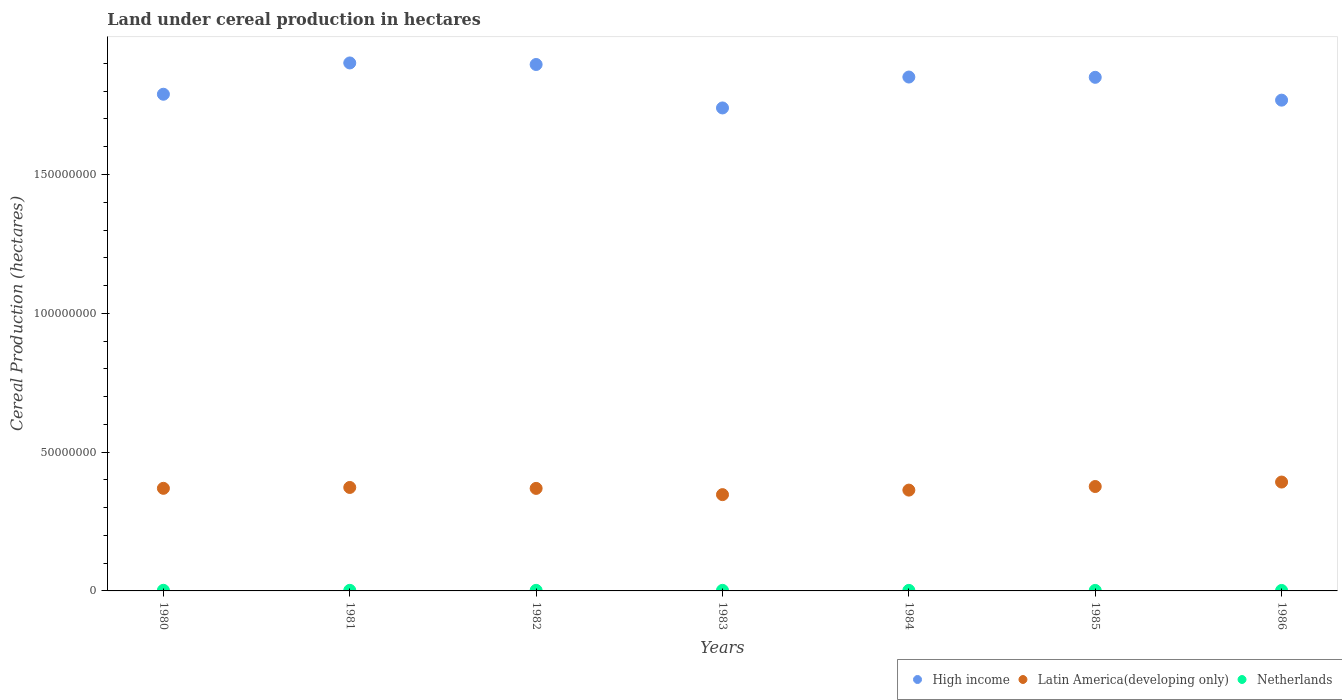What is the land under cereal production in Latin America(developing only) in 1982?
Offer a terse response. 3.69e+07. Across all years, what is the maximum land under cereal production in Latin America(developing only)?
Keep it short and to the point. 3.92e+07. Across all years, what is the minimum land under cereal production in High income?
Offer a very short reply. 1.74e+08. In which year was the land under cereal production in Netherlands minimum?
Ensure brevity in your answer.  1986. What is the total land under cereal production in Netherlands in the graph?
Provide a short and direct response. 1.40e+06. What is the difference between the land under cereal production in Latin America(developing only) in 1983 and that in 1984?
Keep it short and to the point. -1.63e+06. What is the difference between the land under cereal production in Netherlands in 1984 and the land under cereal production in High income in 1982?
Offer a very short reply. -1.89e+08. What is the average land under cereal production in Latin America(developing only) per year?
Offer a very short reply. 3.70e+07. In the year 1983, what is the difference between the land under cereal production in Latin America(developing only) and land under cereal production in High income?
Your answer should be compact. -1.39e+08. What is the ratio of the land under cereal production in Netherlands in 1984 to that in 1985?
Your answer should be compact. 1.07. Is the land under cereal production in Netherlands in 1980 less than that in 1983?
Keep it short and to the point. No. Is the difference between the land under cereal production in Latin America(developing only) in 1984 and 1985 greater than the difference between the land under cereal production in High income in 1984 and 1985?
Make the answer very short. No. What is the difference between the highest and the second highest land under cereal production in Latin America(developing only)?
Ensure brevity in your answer.  1.61e+06. What is the difference between the highest and the lowest land under cereal production in Netherlands?
Offer a terse response. 5.39e+04. Is it the case that in every year, the sum of the land under cereal production in High income and land under cereal production in Latin America(developing only)  is greater than the land under cereal production in Netherlands?
Provide a succinct answer. Yes. Is the land under cereal production in Netherlands strictly less than the land under cereal production in High income over the years?
Keep it short and to the point. Yes. How many dotlines are there?
Give a very brief answer. 3. How many years are there in the graph?
Offer a very short reply. 7. What is the difference between two consecutive major ticks on the Y-axis?
Your answer should be compact. 5.00e+07. Are the values on the major ticks of Y-axis written in scientific E-notation?
Your answer should be very brief. No. How are the legend labels stacked?
Give a very brief answer. Horizontal. What is the title of the graph?
Make the answer very short. Land under cereal production in hectares. Does "Lower middle income" appear as one of the legend labels in the graph?
Your response must be concise. No. What is the label or title of the X-axis?
Your answer should be very brief. Years. What is the label or title of the Y-axis?
Provide a succinct answer. Cereal Production (hectares). What is the Cereal Production (hectares) of High income in 1980?
Offer a terse response. 1.79e+08. What is the Cereal Production (hectares) in Latin America(developing only) in 1980?
Your answer should be very brief. 3.70e+07. What is the Cereal Production (hectares) of Netherlands in 1980?
Give a very brief answer. 2.24e+05. What is the Cereal Production (hectares) of High income in 1981?
Give a very brief answer. 1.90e+08. What is the Cereal Production (hectares) in Latin America(developing only) in 1981?
Your response must be concise. 3.73e+07. What is the Cereal Production (hectares) of Netherlands in 1981?
Offer a very short reply. 2.13e+05. What is the Cereal Production (hectares) of High income in 1982?
Ensure brevity in your answer.  1.90e+08. What is the Cereal Production (hectares) of Latin America(developing only) in 1982?
Make the answer very short. 3.69e+07. What is the Cereal Production (hectares) in Netherlands in 1982?
Provide a succinct answer. 2.05e+05. What is the Cereal Production (hectares) in High income in 1983?
Ensure brevity in your answer.  1.74e+08. What is the Cereal Production (hectares) in Latin America(developing only) in 1983?
Make the answer very short. 3.47e+07. What is the Cereal Production (hectares) of Netherlands in 1983?
Provide a short and direct response. 2.06e+05. What is the Cereal Production (hectares) of High income in 1984?
Give a very brief answer. 1.85e+08. What is the Cereal Production (hectares) of Latin America(developing only) in 1984?
Make the answer very short. 3.63e+07. What is the Cereal Production (hectares) in Netherlands in 1984?
Your answer should be compact. 1.96e+05. What is the Cereal Production (hectares) of High income in 1985?
Your response must be concise. 1.85e+08. What is the Cereal Production (hectares) in Latin America(developing only) in 1985?
Make the answer very short. 3.76e+07. What is the Cereal Production (hectares) of Netherlands in 1985?
Your response must be concise. 1.83e+05. What is the Cereal Production (hectares) in High income in 1986?
Your response must be concise. 1.77e+08. What is the Cereal Production (hectares) of Latin America(developing only) in 1986?
Your response must be concise. 3.92e+07. What is the Cereal Production (hectares) in Netherlands in 1986?
Offer a very short reply. 1.70e+05. Across all years, what is the maximum Cereal Production (hectares) of High income?
Provide a short and direct response. 1.90e+08. Across all years, what is the maximum Cereal Production (hectares) of Latin America(developing only)?
Your response must be concise. 3.92e+07. Across all years, what is the maximum Cereal Production (hectares) in Netherlands?
Keep it short and to the point. 2.24e+05. Across all years, what is the minimum Cereal Production (hectares) of High income?
Your response must be concise. 1.74e+08. Across all years, what is the minimum Cereal Production (hectares) in Latin America(developing only)?
Your answer should be very brief. 3.47e+07. Across all years, what is the minimum Cereal Production (hectares) of Netherlands?
Give a very brief answer. 1.70e+05. What is the total Cereal Production (hectares) in High income in the graph?
Give a very brief answer. 1.28e+09. What is the total Cereal Production (hectares) of Latin America(developing only) in the graph?
Your answer should be compact. 2.59e+08. What is the total Cereal Production (hectares) in Netherlands in the graph?
Ensure brevity in your answer.  1.40e+06. What is the difference between the Cereal Production (hectares) of High income in 1980 and that in 1981?
Provide a succinct answer. -1.13e+07. What is the difference between the Cereal Production (hectares) in Latin America(developing only) in 1980 and that in 1981?
Offer a terse response. -3.14e+05. What is the difference between the Cereal Production (hectares) of Netherlands in 1980 and that in 1981?
Ensure brevity in your answer.  1.08e+04. What is the difference between the Cereal Production (hectares) of High income in 1980 and that in 1982?
Ensure brevity in your answer.  -1.07e+07. What is the difference between the Cereal Production (hectares) in Latin America(developing only) in 1980 and that in 1982?
Offer a very short reply. 2.49e+04. What is the difference between the Cereal Production (hectares) of Netherlands in 1980 and that in 1982?
Your answer should be compact. 1.95e+04. What is the difference between the Cereal Production (hectares) of High income in 1980 and that in 1983?
Offer a terse response. 4.94e+06. What is the difference between the Cereal Production (hectares) in Latin America(developing only) in 1980 and that in 1983?
Provide a succinct answer. 2.27e+06. What is the difference between the Cereal Production (hectares) of Netherlands in 1980 and that in 1983?
Your answer should be very brief. 1.80e+04. What is the difference between the Cereal Production (hectares) of High income in 1980 and that in 1984?
Ensure brevity in your answer.  -6.20e+06. What is the difference between the Cereal Production (hectares) of Latin America(developing only) in 1980 and that in 1984?
Give a very brief answer. 6.42e+05. What is the difference between the Cereal Production (hectares) of Netherlands in 1980 and that in 1984?
Provide a short and direct response. 2.84e+04. What is the difference between the Cereal Production (hectares) of High income in 1980 and that in 1985?
Your answer should be compact. -6.10e+06. What is the difference between the Cereal Production (hectares) of Latin America(developing only) in 1980 and that in 1985?
Your response must be concise. -6.54e+05. What is the difference between the Cereal Production (hectares) in Netherlands in 1980 and that in 1985?
Give a very brief answer. 4.07e+04. What is the difference between the Cereal Production (hectares) in High income in 1980 and that in 1986?
Provide a short and direct response. 2.13e+06. What is the difference between the Cereal Production (hectares) of Latin America(developing only) in 1980 and that in 1986?
Give a very brief answer. -2.26e+06. What is the difference between the Cereal Production (hectares) of Netherlands in 1980 and that in 1986?
Your response must be concise. 5.39e+04. What is the difference between the Cereal Production (hectares) of High income in 1981 and that in 1982?
Give a very brief answer. 5.56e+05. What is the difference between the Cereal Production (hectares) of Latin America(developing only) in 1981 and that in 1982?
Provide a short and direct response. 3.39e+05. What is the difference between the Cereal Production (hectares) in Netherlands in 1981 and that in 1982?
Ensure brevity in your answer.  8707. What is the difference between the Cereal Production (hectares) in High income in 1981 and that in 1983?
Ensure brevity in your answer.  1.62e+07. What is the difference between the Cereal Production (hectares) of Latin America(developing only) in 1981 and that in 1983?
Ensure brevity in your answer.  2.59e+06. What is the difference between the Cereal Production (hectares) of Netherlands in 1981 and that in 1983?
Keep it short and to the point. 7226. What is the difference between the Cereal Production (hectares) of High income in 1981 and that in 1984?
Provide a short and direct response. 5.07e+06. What is the difference between the Cereal Production (hectares) in Latin America(developing only) in 1981 and that in 1984?
Your answer should be compact. 9.56e+05. What is the difference between the Cereal Production (hectares) in Netherlands in 1981 and that in 1984?
Your answer should be very brief. 1.76e+04. What is the difference between the Cereal Production (hectares) of High income in 1981 and that in 1985?
Give a very brief answer. 5.18e+06. What is the difference between the Cereal Production (hectares) in Latin America(developing only) in 1981 and that in 1985?
Give a very brief answer. -3.40e+05. What is the difference between the Cereal Production (hectares) of Netherlands in 1981 and that in 1985?
Give a very brief answer. 2.99e+04. What is the difference between the Cereal Production (hectares) in High income in 1981 and that in 1986?
Make the answer very short. 1.34e+07. What is the difference between the Cereal Production (hectares) of Latin America(developing only) in 1981 and that in 1986?
Your answer should be very brief. -1.95e+06. What is the difference between the Cereal Production (hectares) in Netherlands in 1981 and that in 1986?
Your response must be concise. 4.31e+04. What is the difference between the Cereal Production (hectares) of High income in 1982 and that in 1983?
Make the answer very short. 1.57e+07. What is the difference between the Cereal Production (hectares) of Latin America(developing only) in 1982 and that in 1983?
Provide a short and direct response. 2.25e+06. What is the difference between the Cereal Production (hectares) of Netherlands in 1982 and that in 1983?
Your response must be concise. -1481. What is the difference between the Cereal Production (hectares) in High income in 1982 and that in 1984?
Provide a succinct answer. 4.52e+06. What is the difference between the Cereal Production (hectares) in Latin America(developing only) in 1982 and that in 1984?
Your answer should be very brief. 6.17e+05. What is the difference between the Cereal Production (hectares) in Netherlands in 1982 and that in 1984?
Ensure brevity in your answer.  8897. What is the difference between the Cereal Production (hectares) in High income in 1982 and that in 1985?
Ensure brevity in your answer.  4.62e+06. What is the difference between the Cereal Production (hectares) in Latin America(developing only) in 1982 and that in 1985?
Keep it short and to the point. -6.79e+05. What is the difference between the Cereal Production (hectares) of Netherlands in 1982 and that in 1985?
Offer a terse response. 2.12e+04. What is the difference between the Cereal Production (hectares) of High income in 1982 and that in 1986?
Provide a short and direct response. 1.28e+07. What is the difference between the Cereal Production (hectares) of Latin America(developing only) in 1982 and that in 1986?
Give a very brief answer. -2.28e+06. What is the difference between the Cereal Production (hectares) of Netherlands in 1982 and that in 1986?
Your answer should be compact. 3.43e+04. What is the difference between the Cereal Production (hectares) in High income in 1983 and that in 1984?
Ensure brevity in your answer.  -1.11e+07. What is the difference between the Cereal Production (hectares) of Latin America(developing only) in 1983 and that in 1984?
Make the answer very short. -1.63e+06. What is the difference between the Cereal Production (hectares) in Netherlands in 1983 and that in 1984?
Offer a terse response. 1.04e+04. What is the difference between the Cereal Production (hectares) of High income in 1983 and that in 1985?
Keep it short and to the point. -1.10e+07. What is the difference between the Cereal Production (hectares) in Latin America(developing only) in 1983 and that in 1985?
Provide a short and direct response. -2.93e+06. What is the difference between the Cereal Production (hectares) in Netherlands in 1983 and that in 1985?
Offer a very short reply. 2.27e+04. What is the difference between the Cereal Production (hectares) of High income in 1983 and that in 1986?
Ensure brevity in your answer.  -2.81e+06. What is the difference between the Cereal Production (hectares) in Latin America(developing only) in 1983 and that in 1986?
Give a very brief answer. -4.53e+06. What is the difference between the Cereal Production (hectares) in Netherlands in 1983 and that in 1986?
Offer a very short reply. 3.58e+04. What is the difference between the Cereal Production (hectares) in High income in 1984 and that in 1985?
Provide a short and direct response. 1.01e+05. What is the difference between the Cereal Production (hectares) of Latin America(developing only) in 1984 and that in 1985?
Offer a terse response. -1.30e+06. What is the difference between the Cereal Production (hectares) of Netherlands in 1984 and that in 1985?
Give a very brief answer. 1.23e+04. What is the difference between the Cereal Production (hectares) of High income in 1984 and that in 1986?
Make the answer very short. 8.32e+06. What is the difference between the Cereal Production (hectares) in Latin America(developing only) in 1984 and that in 1986?
Offer a very short reply. -2.90e+06. What is the difference between the Cereal Production (hectares) in Netherlands in 1984 and that in 1986?
Your answer should be very brief. 2.54e+04. What is the difference between the Cereal Production (hectares) in High income in 1985 and that in 1986?
Provide a short and direct response. 8.22e+06. What is the difference between the Cereal Production (hectares) in Latin America(developing only) in 1985 and that in 1986?
Make the answer very short. -1.61e+06. What is the difference between the Cereal Production (hectares) in Netherlands in 1985 and that in 1986?
Your answer should be very brief. 1.31e+04. What is the difference between the Cereal Production (hectares) in High income in 1980 and the Cereal Production (hectares) in Latin America(developing only) in 1981?
Your answer should be compact. 1.42e+08. What is the difference between the Cereal Production (hectares) in High income in 1980 and the Cereal Production (hectares) in Netherlands in 1981?
Give a very brief answer. 1.79e+08. What is the difference between the Cereal Production (hectares) of Latin America(developing only) in 1980 and the Cereal Production (hectares) of Netherlands in 1981?
Give a very brief answer. 3.67e+07. What is the difference between the Cereal Production (hectares) in High income in 1980 and the Cereal Production (hectares) in Latin America(developing only) in 1982?
Your response must be concise. 1.42e+08. What is the difference between the Cereal Production (hectares) of High income in 1980 and the Cereal Production (hectares) of Netherlands in 1982?
Provide a short and direct response. 1.79e+08. What is the difference between the Cereal Production (hectares) of Latin America(developing only) in 1980 and the Cereal Production (hectares) of Netherlands in 1982?
Give a very brief answer. 3.68e+07. What is the difference between the Cereal Production (hectares) in High income in 1980 and the Cereal Production (hectares) in Latin America(developing only) in 1983?
Give a very brief answer. 1.44e+08. What is the difference between the Cereal Production (hectares) in High income in 1980 and the Cereal Production (hectares) in Netherlands in 1983?
Ensure brevity in your answer.  1.79e+08. What is the difference between the Cereal Production (hectares) in Latin America(developing only) in 1980 and the Cereal Production (hectares) in Netherlands in 1983?
Provide a succinct answer. 3.68e+07. What is the difference between the Cereal Production (hectares) of High income in 1980 and the Cereal Production (hectares) of Latin America(developing only) in 1984?
Make the answer very short. 1.43e+08. What is the difference between the Cereal Production (hectares) of High income in 1980 and the Cereal Production (hectares) of Netherlands in 1984?
Your response must be concise. 1.79e+08. What is the difference between the Cereal Production (hectares) of Latin America(developing only) in 1980 and the Cereal Production (hectares) of Netherlands in 1984?
Provide a short and direct response. 3.68e+07. What is the difference between the Cereal Production (hectares) in High income in 1980 and the Cereal Production (hectares) in Latin America(developing only) in 1985?
Offer a very short reply. 1.41e+08. What is the difference between the Cereal Production (hectares) of High income in 1980 and the Cereal Production (hectares) of Netherlands in 1985?
Your answer should be compact. 1.79e+08. What is the difference between the Cereal Production (hectares) in Latin America(developing only) in 1980 and the Cereal Production (hectares) in Netherlands in 1985?
Your response must be concise. 3.68e+07. What is the difference between the Cereal Production (hectares) in High income in 1980 and the Cereal Production (hectares) in Latin America(developing only) in 1986?
Provide a short and direct response. 1.40e+08. What is the difference between the Cereal Production (hectares) of High income in 1980 and the Cereal Production (hectares) of Netherlands in 1986?
Offer a very short reply. 1.79e+08. What is the difference between the Cereal Production (hectares) in Latin America(developing only) in 1980 and the Cereal Production (hectares) in Netherlands in 1986?
Your response must be concise. 3.68e+07. What is the difference between the Cereal Production (hectares) in High income in 1981 and the Cereal Production (hectares) in Latin America(developing only) in 1982?
Provide a short and direct response. 1.53e+08. What is the difference between the Cereal Production (hectares) in High income in 1981 and the Cereal Production (hectares) in Netherlands in 1982?
Keep it short and to the point. 1.90e+08. What is the difference between the Cereal Production (hectares) of Latin America(developing only) in 1981 and the Cereal Production (hectares) of Netherlands in 1982?
Offer a terse response. 3.71e+07. What is the difference between the Cereal Production (hectares) of High income in 1981 and the Cereal Production (hectares) of Latin America(developing only) in 1983?
Make the answer very short. 1.56e+08. What is the difference between the Cereal Production (hectares) of High income in 1981 and the Cereal Production (hectares) of Netherlands in 1983?
Offer a terse response. 1.90e+08. What is the difference between the Cereal Production (hectares) of Latin America(developing only) in 1981 and the Cereal Production (hectares) of Netherlands in 1983?
Offer a terse response. 3.71e+07. What is the difference between the Cereal Production (hectares) in High income in 1981 and the Cereal Production (hectares) in Latin America(developing only) in 1984?
Your answer should be very brief. 1.54e+08. What is the difference between the Cereal Production (hectares) of High income in 1981 and the Cereal Production (hectares) of Netherlands in 1984?
Make the answer very short. 1.90e+08. What is the difference between the Cereal Production (hectares) in Latin America(developing only) in 1981 and the Cereal Production (hectares) in Netherlands in 1984?
Make the answer very short. 3.71e+07. What is the difference between the Cereal Production (hectares) in High income in 1981 and the Cereal Production (hectares) in Latin America(developing only) in 1985?
Your answer should be very brief. 1.53e+08. What is the difference between the Cereal Production (hectares) in High income in 1981 and the Cereal Production (hectares) in Netherlands in 1985?
Your answer should be compact. 1.90e+08. What is the difference between the Cereal Production (hectares) of Latin America(developing only) in 1981 and the Cereal Production (hectares) of Netherlands in 1985?
Provide a succinct answer. 3.71e+07. What is the difference between the Cereal Production (hectares) of High income in 1981 and the Cereal Production (hectares) of Latin America(developing only) in 1986?
Offer a terse response. 1.51e+08. What is the difference between the Cereal Production (hectares) of High income in 1981 and the Cereal Production (hectares) of Netherlands in 1986?
Your answer should be compact. 1.90e+08. What is the difference between the Cereal Production (hectares) of Latin America(developing only) in 1981 and the Cereal Production (hectares) of Netherlands in 1986?
Give a very brief answer. 3.71e+07. What is the difference between the Cereal Production (hectares) in High income in 1982 and the Cereal Production (hectares) in Latin America(developing only) in 1983?
Ensure brevity in your answer.  1.55e+08. What is the difference between the Cereal Production (hectares) in High income in 1982 and the Cereal Production (hectares) in Netherlands in 1983?
Provide a short and direct response. 1.89e+08. What is the difference between the Cereal Production (hectares) of Latin America(developing only) in 1982 and the Cereal Production (hectares) of Netherlands in 1983?
Provide a short and direct response. 3.67e+07. What is the difference between the Cereal Production (hectares) of High income in 1982 and the Cereal Production (hectares) of Latin America(developing only) in 1984?
Your answer should be very brief. 1.53e+08. What is the difference between the Cereal Production (hectares) of High income in 1982 and the Cereal Production (hectares) of Netherlands in 1984?
Keep it short and to the point. 1.89e+08. What is the difference between the Cereal Production (hectares) in Latin America(developing only) in 1982 and the Cereal Production (hectares) in Netherlands in 1984?
Offer a very short reply. 3.67e+07. What is the difference between the Cereal Production (hectares) in High income in 1982 and the Cereal Production (hectares) in Latin America(developing only) in 1985?
Give a very brief answer. 1.52e+08. What is the difference between the Cereal Production (hectares) of High income in 1982 and the Cereal Production (hectares) of Netherlands in 1985?
Make the answer very short. 1.89e+08. What is the difference between the Cereal Production (hectares) in Latin America(developing only) in 1982 and the Cereal Production (hectares) in Netherlands in 1985?
Ensure brevity in your answer.  3.67e+07. What is the difference between the Cereal Production (hectares) in High income in 1982 and the Cereal Production (hectares) in Latin America(developing only) in 1986?
Your answer should be very brief. 1.50e+08. What is the difference between the Cereal Production (hectares) in High income in 1982 and the Cereal Production (hectares) in Netherlands in 1986?
Your answer should be compact. 1.89e+08. What is the difference between the Cereal Production (hectares) in Latin America(developing only) in 1982 and the Cereal Production (hectares) in Netherlands in 1986?
Your answer should be very brief. 3.68e+07. What is the difference between the Cereal Production (hectares) in High income in 1983 and the Cereal Production (hectares) in Latin America(developing only) in 1984?
Offer a very short reply. 1.38e+08. What is the difference between the Cereal Production (hectares) in High income in 1983 and the Cereal Production (hectares) in Netherlands in 1984?
Offer a very short reply. 1.74e+08. What is the difference between the Cereal Production (hectares) in Latin America(developing only) in 1983 and the Cereal Production (hectares) in Netherlands in 1984?
Provide a short and direct response. 3.45e+07. What is the difference between the Cereal Production (hectares) of High income in 1983 and the Cereal Production (hectares) of Latin America(developing only) in 1985?
Make the answer very short. 1.36e+08. What is the difference between the Cereal Production (hectares) of High income in 1983 and the Cereal Production (hectares) of Netherlands in 1985?
Your answer should be compact. 1.74e+08. What is the difference between the Cereal Production (hectares) in Latin America(developing only) in 1983 and the Cereal Production (hectares) in Netherlands in 1985?
Make the answer very short. 3.45e+07. What is the difference between the Cereal Production (hectares) in High income in 1983 and the Cereal Production (hectares) in Latin America(developing only) in 1986?
Give a very brief answer. 1.35e+08. What is the difference between the Cereal Production (hectares) of High income in 1983 and the Cereal Production (hectares) of Netherlands in 1986?
Your answer should be very brief. 1.74e+08. What is the difference between the Cereal Production (hectares) in Latin America(developing only) in 1983 and the Cereal Production (hectares) in Netherlands in 1986?
Give a very brief answer. 3.45e+07. What is the difference between the Cereal Production (hectares) in High income in 1984 and the Cereal Production (hectares) in Latin America(developing only) in 1985?
Your answer should be very brief. 1.48e+08. What is the difference between the Cereal Production (hectares) in High income in 1984 and the Cereal Production (hectares) in Netherlands in 1985?
Make the answer very short. 1.85e+08. What is the difference between the Cereal Production (hectares) in Latin America(developing only) in 1984 and the Cereal Production (hectares) in Netherlands in 1985?
Give a very brief answer. 3.61e+07. What is the difference between the Cereal Production (hectares) in High income in 1984 and the Cereal Production (hectares) in Latin America(developing only) in 1986?
Offer a terse response. 1.46e+08. What is the difference between the Cereal Production (hectares) of High income in 1984 and the Cereal Production (hectares) of Netherlands in 1986?
Ensure brevity in your answer.  1.85e+08. What is the difference between the Cereal Production (hectares) of Latin America(developing only) in 1984 and the Cereal Production (hectares) of Netherlands in 1986?
Keep it short and to the point. 3.61e+07. What is the difference between the Cereal Production (hectares) in High income in 1985 and the Cereal Production (hectares) in Latin America(developing only) in 1986?
Offer a very short reply. 1.46e+08. What is the difference between the Cereal Production (hectares) in High income in 1985 and the Cereal Production (hectares) in Netherlands in 1986?
Give a very brief answer. 1.85e+08. What is the difference between the Cereal Production (hectares) of Latin America(developing only) in 1985 and the Cereal Production (hectares) of Netherlands in 1986?
Provide a succinct answer. 3.74e+07. What is the average Cereal Production (hectares) in High income per year?
Provide a short and direct response. 1.83e+08. What is the average Cereal Production (hectares) of Latin America(developing only) per year?
Offer a terse response. 3.70e+07. What is the average Cereal Production (hectares) of Netherlands per year?
Your answer should be compact. 2.00e+05. In the year 1980, what is the difference between the Cereal Production (hectares) of High income and Cereal Production (hectares) of Latin America(developing only)?
Make the answer very short. 1.42e+08. In the year 1980, what is the difference between the Cereal Production (hectares) of High income and Cereal Production (hectares) of Netherlands?
Provide a succinct answer. 1.79e+08. In the year 1980, what is the difference between the Cereal Production (hectares) of Latin America(developing only) and Cereal Production (hectares) of Netherlands?
Offer a very short reply. 3.67e+07. In the year 1981, what is the difference between the Cereal Production (hectares) of High income and Cereal Production (hectares) of Latin America(developing only)?
Offer a terse response. 1.53e+08. In the year 1981, what is the difference between the Cereal Production (hectares) of High income and Cereal Production (hectares) of Netherlands?
Provide a short and direct response. 1.90e+08. In the year 1981, what is the difference between the Cereal Production (hectares) of Latin America(developing only) and Cereal Production (hectares) of Netherlands?
Give a very brief answer. 3.71e+07. In the year 1982, what is the difference between the Cereal Production (hectares) of High income and Cereal Production (hectares) of Latin America(developing only)?
Your answer should be very brief. 1.53e+08. In the year 1982, what is the difference between the Cereal Production (hectares) of High income and Cereal Production (hectares) of Netherlands?
Offer a terse response. 1.89e+08. In the year 1982, what is the difference between the Cereal Production (hectares) in Latin America(developing only) and Cereal Production (hectares) in Netherlands?
Your answer should be very brief. 3.67e+07. In the year 1983, what is the difference between the Cereal Production (hectares) in High income and Cereal Production (hectares) in Latin America(developing only)?
Your answer should be very brief. 1.39e+08. In the year 1983, what is the difference between the Cereal Production (hectares) of High income and Cereal Production (hectares) of Netherlands?
Give a very brief answer. 1.74e+08. In the year 1983, what is the difference between the Cereal Production (hectares) in Latin America(developing only) and Cereal Production (hectares) in Netherlands?
Keep it short and to the point. 3.45e+07. In the year 1984, what is the difference between the Cereal Production (hectares) in High income and Cereal Production (hectares) in Latin America(developing only)?
Ensure brevity in your answer.  1.49e+08. In the year 1984, what is the difference between the Cereal Production (hectares) of High income and Cereal Production (hectares) of Netherlands?
Keep it short and to the point. 1.85e+08. In the year 1984, what is the difference between the Cereal Production (hectares) of Latin America(developing only) and Cereal Production (hectares) of Netherlands?
Keep it short and to the point. 3.61e+07. In the year 1985, what is the difference between the Cereal Production (hectares) in High income and Cereal Production (hectares) in Latin America(developing only)?
Your answer should be compact. 1.47e+08. In the year 1985, what is the difference between the Cereal Production (hectares) in High income and Cereal Production (hectares) in Netherlands?
Provide a short and direct response. 1.85e+08. In the year 1985, what is the difference between the Cereal Production (hectares) in Latin America(developing only) and Cereal Production (hectares) in Netherlands?
Provide a short and direct response. 3.74e+07. In the year 1986, what is the difference between the Cereal Production (hectares) of High income and Cereal Production (hectares) of Latin America(developing only)?
Provide a short and direct response. 1.38e+08. In the year 1986, what is the difference between the Cereal Production (hectares) of High income and Cereal Production (hectares) of Netherlands?
Provide a short and direct response. 1.77e+08. In the year 1986, what is the difference between the Cereal Production (hectares) in Latin America(developing only) and Cereal Production (hectares) in Netherlands?
Your answer should be compact. 3.90e+07. What is the ratio of the Cereal Production (hectares) in High income in 1980 to that in 1981?
Your answer should be very brief. 0.94. What is the ratio of the Cereal Production (hectares) in Latin America(developing only) in 1980 to that in 1981?
Your answer should be very brief. 0.99. What is the ratio of the Cereal Production (hectares) in Netherlands in 1980 to that in 1981?
Offer a terse response. 1.05. What is the ratio of the Cereal Production (hectares) of High income in 1980 to that in 1982?
Your response must be concise. 0.94. What is the ratio of the Cereal Production (hectares) of Netherlands in 1980 to that in 1982?
Provide a succinct answer. 1.1. What is the ratio of the Cereal Production (hectares) of High income in 1980 to that in 1983?
Provide a short and direct response. 1.03. What is the ratio of the Cereal Production (hectares) in Latin America(developing only) in 1980 to that in 1983?
Your answer should be compact. 1.07. What is the ratio of the Cereal Production (hectares) of Netherlands in 1980 to that in 1983?
Your answer should be very brief. 1.09. What is the ratio of the Cereal Production (hectares) of High income in 1980 to that in 1984?
Provide a short and direct response. 0.97. What is the ratio of the Cereal Production (hectares) of Latin America(developing only) in 1980 to that in 1984?
Ensure brevity in your answer.  1.02. What is the ratio of the Cereal Production (hectares) in Netherlands in 1980 to that in 1984?
Ensure brevity in your answer.  1.15. What is the ratio of the Cereal Production (hectares) of High income in 1980 to that in 1985?
Offer a very short reply. 0.97. What is the ratio of the Cereal Production (hectares) in Latin America(developing only) in 1980 to that in 1985?
Offer a very short reply. 0.98. What is the ratio of the Cereal Production (hectares) in Netherlands in 1980 to that in 1985?
Provide a succinct answer. 1.22. What is the ratio of the Cereal Production (hectares) in Latin America(developing only) in 1980 to that in 1986?
Make the answer very short. 0.94. What is the ratio of the Cereal Production (hectares) in Netherlands in 1980 to that in 1986?
Make the answer very short. 1.32. What is the ratio of the Cereal Production (hectares) in High income in 1981 to that in 1982?
Offer a very short reply. 1. What is the ratio of the Cereal Production (hectares) of Latin America(developing only) in 1981 to that in 1982?
Offer a terse response. 1.01. What is the ratio of the Cereal Production (hectares) in Netherlands in 1981 to that in 1982?
Your answer should be very brief. 1.04. What is the ratio of the Cereal Production (hectares) of High income in 1981 to that in 1983?
Offer a very short reply. 1.09. What is the ratio of the Cereal Production (hectares) in Latin America(developing only) in 1981 to that in 1983?
Provide a short and direct response. 1.07. What is the ratio of the Cereal Production (hectares) of Netherlands in 1981 to that in 1983?
Your answer should be very brief. 1.04. What is the ratio of the Cereal Production (hectares) of High income in 1981 to that in 1984?
Offer a very short reply. 1.03. What is the ratio of the Cereal Production (hectares) in Latin America(developing only) in 1981 to that in 1984?
Provide a succinct answer. 1.03. What is the ratio of the Cereal Production (hectares) of Netherlands in 1981 to that in 1984?
Offer a very short reply. 1.09. What is the ratio of the Cereal Production (hectares) of High income in 1981 to that in 1985?
Make the answer very short. 1.03. What is the ratio of the Cereal Production (hectares) of Latin America(developing only) in 1981 to that in 1985?
Offer a very short reply. 0.99. What is the ratio of the Cereal Production (hectares) in Netherlands in 1981 to that in 1985?
Provide a short and direct response. 1.16. What is the ratio of the Cereal Production (hectares) of High income in 1981 to that in 1986?
Offer a very short reply. 1.08. What is the ratio of the Cereal Production (hectares) of Latin America(developing only) in 1981 to that in 1986?
Your response must be concise. 0.95. What is the ratio of the Cereal Production (hectares) of Netherlands in 1981 to that in 1986?
Your answer should be compact. 1.25. What is the ratio of the Cereal Production (hectares) of High income in 1982 to that in 1983?
Give a very brief answer. 1.09. What is the ratio of the Cereal Production (hectares) of Latin America(developing only) in 1982 to that in 1983?
Give a very brief answer. 1.06. What is the ratio of the Cereal Production (hectares) of High income in 1982 to that in 1984?
Ensure brevity in your answer.  1.02. What is the ratio of the Cereal Production (hectares) in Netherlands in 1982 to that in 1984?
Keep it short and to the point. 1.05. What is the ratio of the Cereal Production (hectares) of Latin America(developing only) in 1982 to that in 1985?
Provide a succinct answer. 0.98. What is the ratio of the Cereal Production (hectares) of Netherlands in 1982 to that in 1985?
Offer a terse response. 1.12. What is the ratio of the Cereal Production (hectares) in High income in 1982 to that in 1986?
Offer a terse response. 1.07. What is the ratio of the Cereal Production (hectares) of Latin America(developing only) in 1982 to that in 1986?
Your answer should be very brief. 0.94. What is the ratio of the Cereal Production (hectares) in Netherlands in 1982 to that in 1986?
Make the answer very short. 1.2. What is the ratio of the Cereal Production (hectares) of High income in 1983 to that in 1984?
Provide a short and direct response. 0.94. What is the ratio of the Cereal Production (hectares) of Latin America(developing only) in 1983 to that in 1984?
Ensure brevity in your answer.  0.96. What is the ratio of the Cereal Production (hectares) in Netherlands in 1983 to that in 1984?
Offer a terse response. 1.05. What is the ratio of the Cereal Production (hectares) in High income in 1983 to that in 1985?
Your answer should be very brief. 0.94. What is the ratio of the Cereal Production (hectares) in Latin America(developing only) in 1983 to that in 1985?
Provide a short and direct response. 0.92. What is the ratio of the Cereal Production (hectares) of Netherlands in 1983 to that in 1985?
Your response must be concise. 1.12. What is the ratio of the Cereal Production (hectares) of High income in 1983 to that in 1986?
Make the answer very short. 0.98. What is the ratio of the Cereal Production (hectares) of Latin America(developing only) in 1983 to that in 1986?
Give a very brief answer. 0.88. What is the ratio of the Cereal Production (hectares) in Netherlands in 1983 to that in 1986?
Ensure brevity in your answer.  1.21. What is the ratio of the Cereal Production (hectares) in Latin America(developing only) in 1984 to that in 1985?
Provide a short and direct response. 0.97. What is the ratio of the Cereal Production (hectares) in Netherlands in 1984 to that in 1985?
Your answer should be compact. 1.07. What is the ratio of the Cereal Production (hectares) in High income in 1984 to that in 1986?
Provide a short and direct response. 1.05. What is the ratio of the Cereal Production (hectares) in Latin America(developing only) in 1984 to that in 1986?
Provide a succinct answer. 0.93. What is the ratio of the Cereal Production (hectares) in Netherlands in 1984 to that in 1986?
Keep it short and to the point. 1.15. What is the ratio of the Cereal Production (hectares) of High income in 1985 to that in 1986?
Provide a short and direct response. 1.05. What is the ratio of the Cereal Production (hectares) in Latin America(developing only) in 1985 to that in 1986?
Offer a very short reply. 0.96. What is the ratio of the Cereal Production (hectares) of Netherlands in 1985 to that in 1986?
Provide a short and direct response. 1.08. What is the difference between the highest and the second highest Cereal Production (hectares) in High income?
Your answer should be very brief. 5.56e+05. What is the difference between the highest and the second highest Cereal Production (hectares) in Latin America(developing only)?
Offer a terse response. 1.61e+06. What is the difference between the highest and the second highest Cereal Production (hectares) of Netherlands?
Provide a succinct answer. 1.08e+04. What is the difference between the highest and the lowest Cereal Production (hectares) of High income?
Keep it short and to the point. 1.62e+07. What is the difference between the highest and the lowest Cereal Production (hectares) of Latin America(developing only)?
Provide a succinct answer. 4.53e+06. What is the difference between the highest and the lowest Cereal Production (hectares) of Netherlands?
Your answer should be compact. 5.39e+04. 